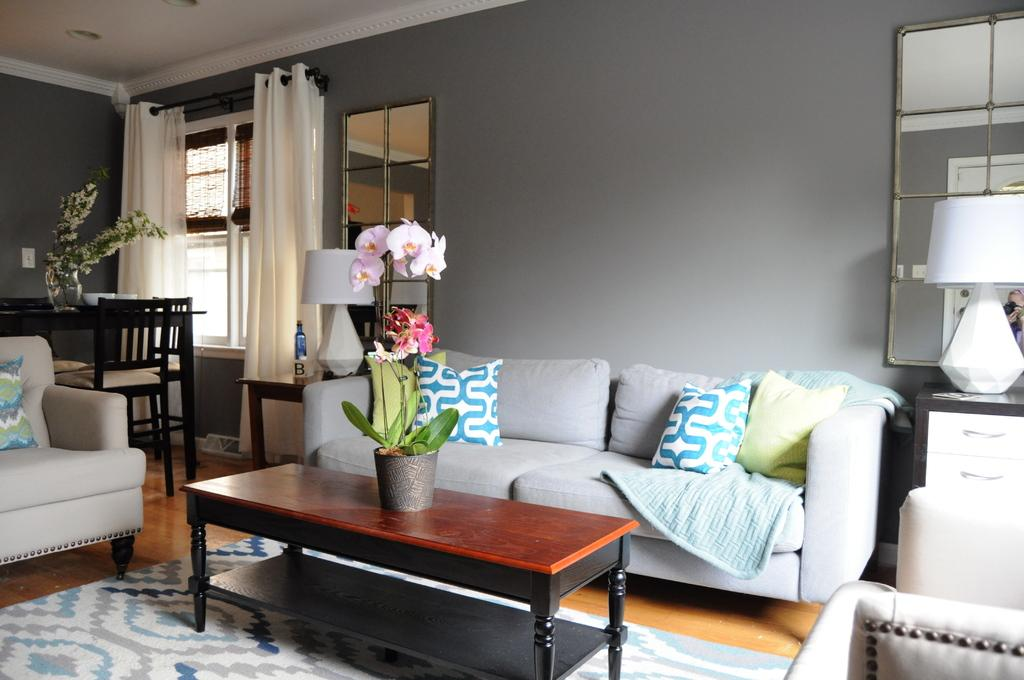What type of furniture is present in the image? There is a couch and a dining table in the image. What other object can be seen in the image? There is a teapoy in the image. What is placed on the teapoy? There is a flower vase on the teapoy. What architectural feature is visible in the image? There is a window with curtains in the image. How many legs does the zinc have in the image? There is no zinc present in the image, so it is not possible to determine the number of legs it might have. 